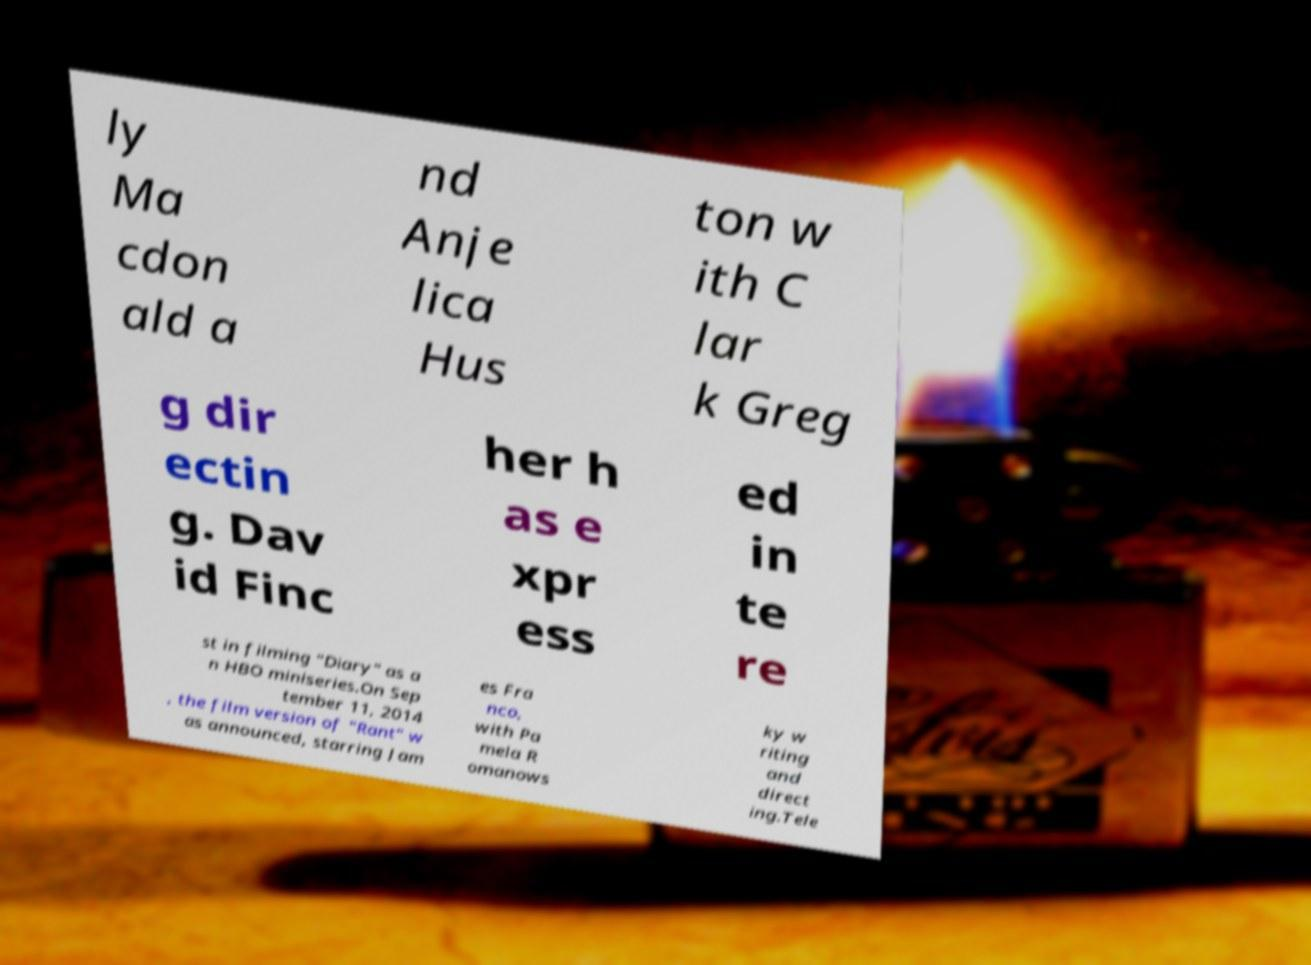Could you extract and type out the text from this image? ly Ma cdon ald a nd Anje lica Hus ton w ith C lar k Greg g dir ectin g. Dav id Finc her h as e xpr ess ed in te re st in filming "Diary" as a n HBO miniseries.On Sep tember 11, 2014 , the film version of "Rant" w as announced, starring Jam es Fra nco, with Pa mela R omanows ky w riting and direct ing.Tele 